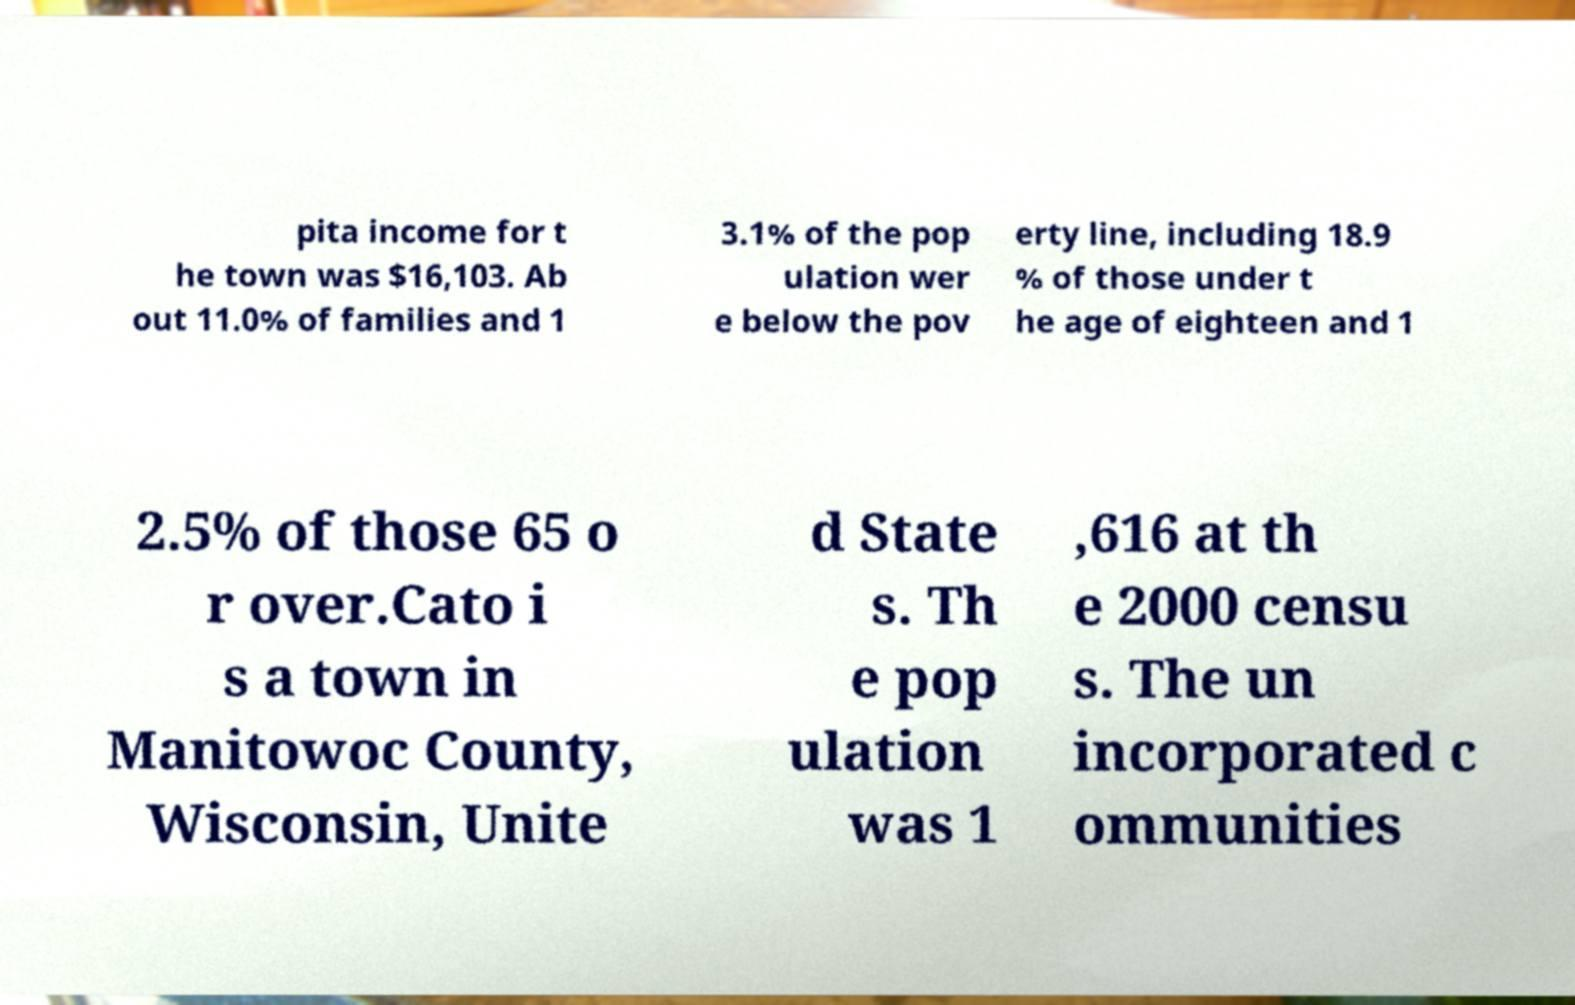I need the written content from this picture converted into text. Can you do that? pita income for t he town was $16,103. Ab out 11.0% of families and 1 3.1% of the pop ulation wer e below the pov erty line, including 18.9 % of those under t he age of eighteen and 1 2.5% of those 65 o r over.Cato i s a town in Manitowoc County, Wisconsin, Unite d State s. Th e pop ulation was 1 ,616 at th e 2000 censu s. The un incorporated c ommunities 